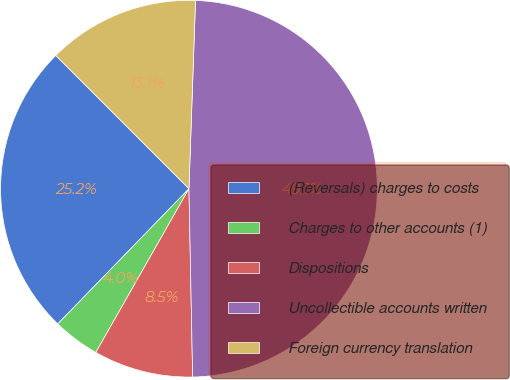Convert chart. <chart><loc_0><loc_0><loc_500><loc_500><pie_chart><fcel>(Reversals) charges to costs<fcel>Charges to other accounts (1)<fcel>Dispositions<fcel>Uncollectible accounts written<fcel>Foreign currency translation<nl><fcel>25.24%<fcel>4.03%<fcel>8.54%<fcel>49.13%<fcel>13.05%<nl></chart> 